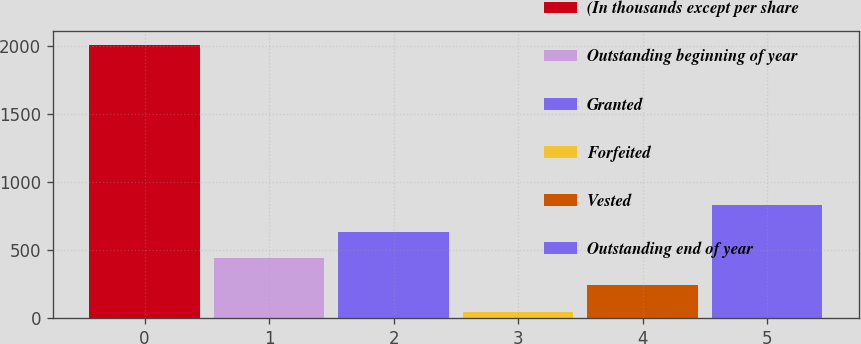Convert chart. <chart><loc_0><loc_0><loc_500><loc_500><bar_chart><fcel>(In thousands except per share<fcel>Outstanding beginning of year<fcel>Granted<fcel>Forfeited<fcel>Vested<fcel>Outstanding end of year<nl><fcel>2008<fcel>437.6<fcel>633.9<fcel>45<fcel>241.3<fcel>830.2<nl></chart> 